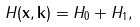<formula> <loc_0><loc_0><loc_500><loc_500>H ( { \mathbf x } , { \mathbf k } ) = H _ { 0 } + H _ { 1 } ,</formula> 